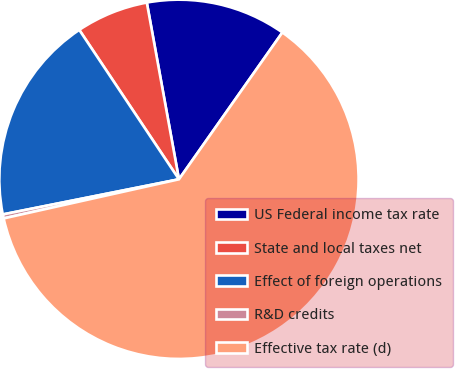Convert chart to OTSL. <chart><loc_0><loc_0><loc_500><loc_500><pie_chart><fcel>US Federal income tax rate<fcel>State and local taxes net<fcel>Effect of foreign operations<fcel>R&D credits<fcel>Effective tax rate (d)<nl><fcel>12.63%<fcel>6.5%<fcel>18.77%<fcel>0.36%<fcel>61.74%<nl></chart> 